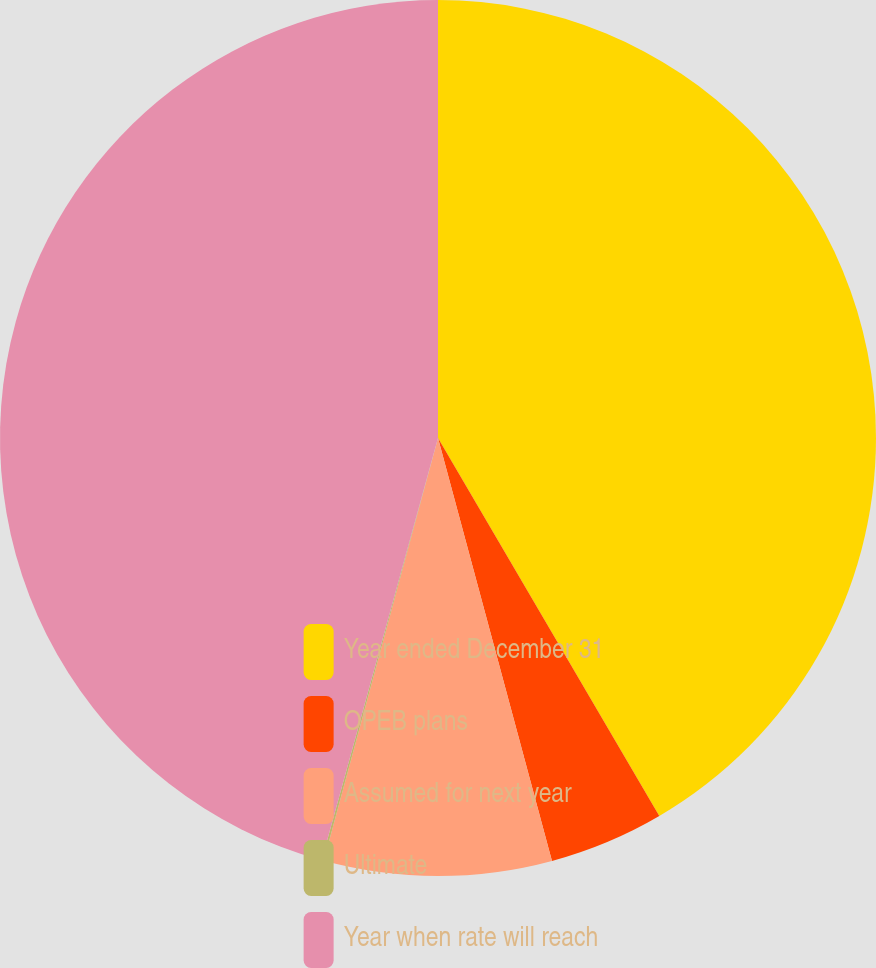Convert chart. <chart><loc_0><loc_0><loc_500><loc_500><pie_chart><fcel>Year ended December 31<fcel>OPEB plans<fcel>Assumed for next year<fcel>Ultimate<fcel>Year when rate will reach<nl><fcel>41.57%<fcel>4.24%<fcel>8.39%<fcel>0.08%<fcel>45.72%<nl></chart> 